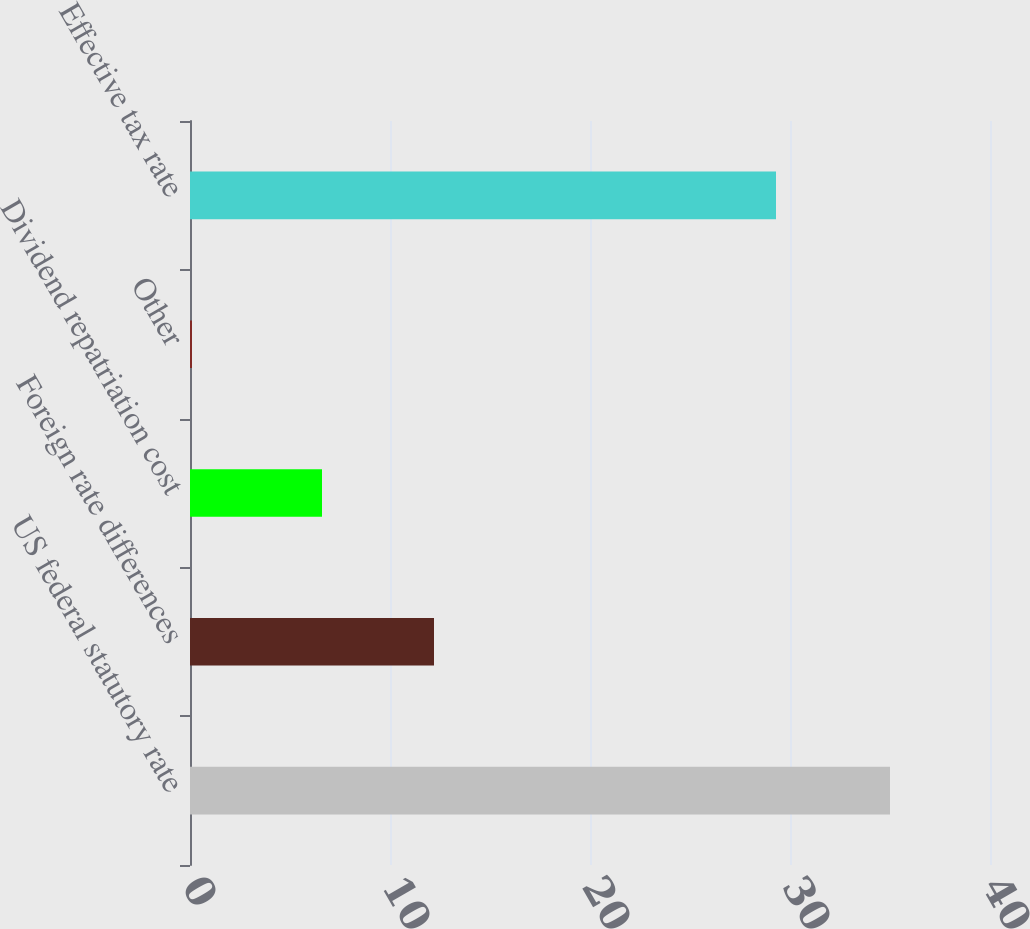Convert chart to OTSL. <chart><loc_0><loc_0><loc_500><loc_500><bar_chart><fcel>US federal statutory rate<fcel>Foreign rate differences<fcel>Dividend repatriation cost<fcel>Other<fcel>Effective tax rate<nl><fcel>35<fcel>12.2<fcel>6.6<fcel>0.1<fcel>29.3<nl></chart> 